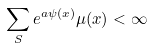Convert formula to latex. <formula><loc_0><loc_0><loc_500><loc_500>\sum _ { S } e ^ { a \psi ( x ) } \mu ( x ) < \infty</formula> 